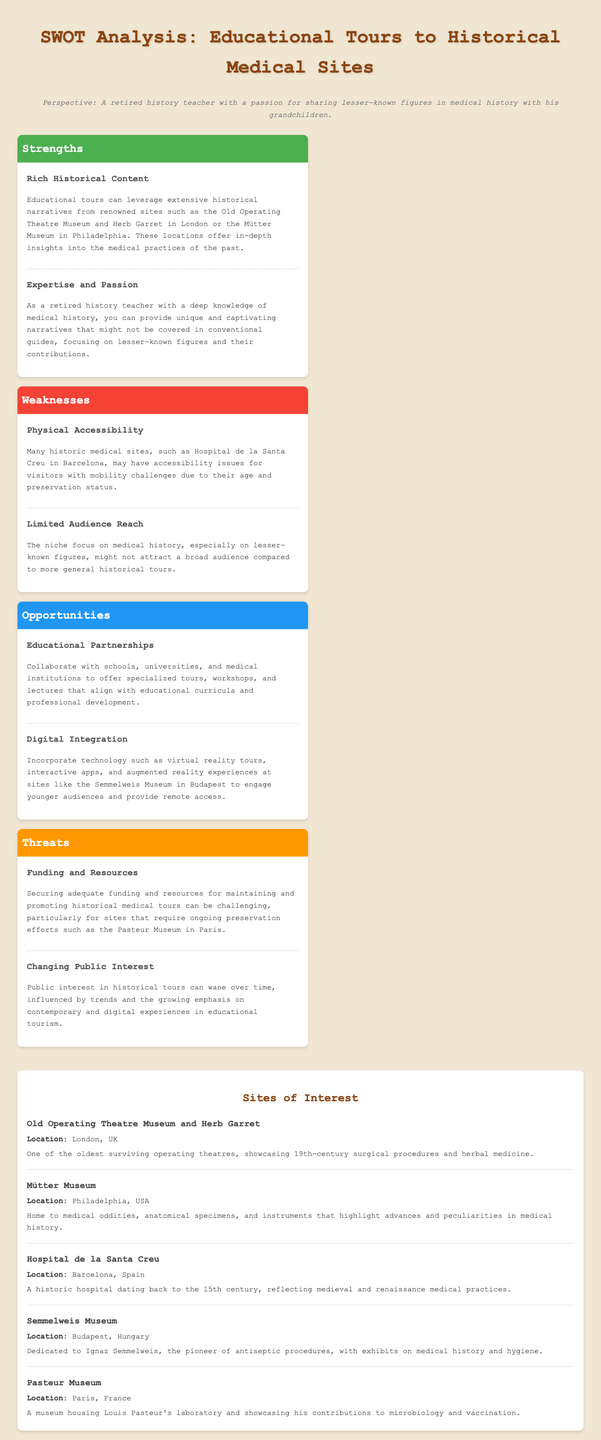what is one of the strengths of organizing educational tours? The document states that one strength is the rich historical content offered by various medical sites.
Answer: rich historical content which site is located in Barcelona? The document mentions the Hospital de la Santa Creu as being in Barcelona.
Answer: Hospital de la Santa Creu what is a weakness mentioned regarding these tours? The document identifies physical accessibility as a weakness for many historic medical sites.
Answer: physical accessibility which museum is dedicated to Ignaz Semmelweis? The Semmelweis Museum in Budapest is dedicated to him, as stated in the document.
Answer: Semmelweis Museum how many sites are listed in the sites of interest section? The document lists five sites of interest.
Answer: five what opportunity involves collaboration with educational institutions? The document mentions educational partnerships as an opportunity for collaboration.
Answer: educational partnerships what threat does the document mention related to public interest? The document states that changing public interest can be a threat to historical tours.
Answer: changing public interest who is the persona of the document? The persona is described as a retired history teacher with a passion for medical history.
Answer: a retired history teacher 